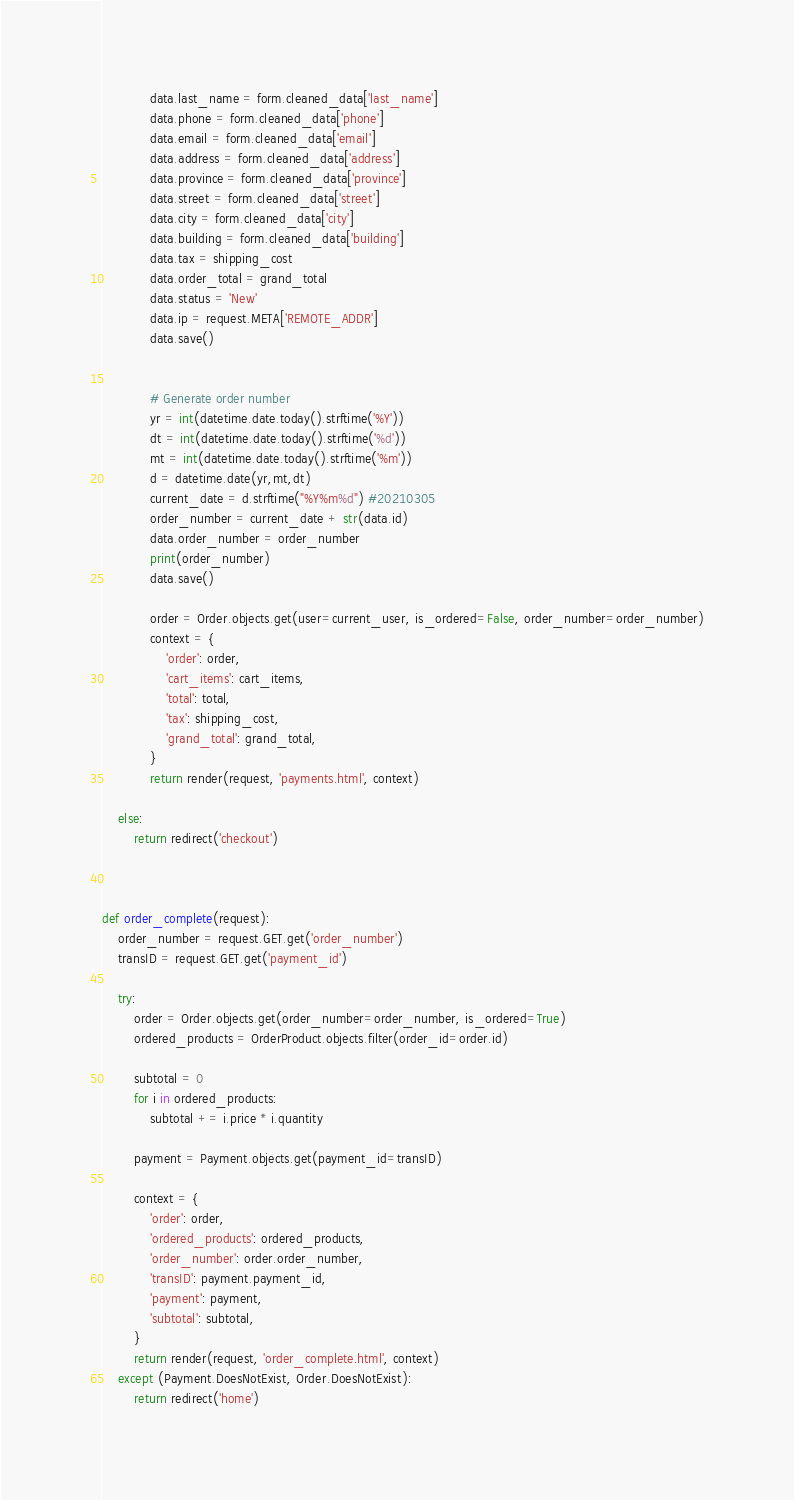Convert code to text. <code><loc_0><loc_0><loc_500><loc_500><_Python_>            data.last_name = form.cleaned_data['last_name']
            data.phone = form.cleaned_data['phone']
            data.email = form.cleaned_data['email']
            data.address = form.cleaned_data['address']
            data.province = form.cleaned_data['province']
            data.street = form.cleaned_data['street']
            data.city = form.cleaned_data['city']
            data.building = form.cleaned_data['building']
            data.tax = shipping_cost
            data.order_total = grand_total
            data.status = 'New'
            data.ip = request.META['REMOTE_ADDR']
            data.save()
            
            
            # Generate order number
            yr = int(datetime.date.today().strftime('%Y'))
            dt = int(datetime.date.today().strftime('%d'))
            mt = int(datetime.date.today().strftime('%m'))
            d = datetime.date(yr,mt,dt)
            current_date = d.strftime("%Y%m%d") #20210305
            order_number = current_date + str(data.id)
            data.order_number = order_number
            print(order_number)
            data.save()

            order = Order.objects.get(user=current_user, is_ordered=False, order_number=order_number)
            context = {
                'order': order,
                'cart_items': cart_items,
                'total': total,
                'tax': shipping_cost,
                'grand_total': grand_total,
            }
            return render(request, 'payments.html', context)

    else:
        return redirect('checkout')

    

def order_complete(request):
    order_number = request.GET.get('order_number')
    transID = request.GET.get('payment_id')

    try:
        order = Order.objects.get(order_number=order_number, is_ordered=True)
        ordered_products = OrderProduct.objects.filter(order_id=order.id)

        subtotal = 0
        for i in ordered_products:
            subtotal += i.price * i.quantity

        payment = Payment.objects.get(payment_id=transID)

        context = {
            'order': order,
            'ordered_products': ordered_products,
            'order_number': order.order_number,
            'transID': payment.payment_id,
            'payment': payment,
            'subtotal': subtotal,
        }
        return render(request, 'order_complete.html', context)
    except (Payment.DoesNotExist, Order.DoesNotExist):
        return redirect('home')</code> 